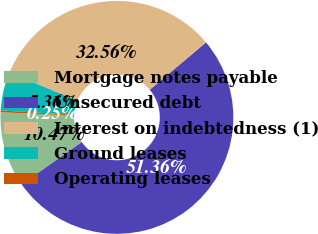Convert chart. <chart><loc_0><loc_0><loc_500><loc_500><pie_chart><fcel>Mortgage notes payable<fcel>Unsecured debt<fcel>Interest on indebtedness (1)<fcel>Ground leases<fcel>Operating leases<nl><fcel>10.47%<fcel>51.36%<fcel>32.56%<fcel>5.36%<fcel>0.25%<nl></chart> 